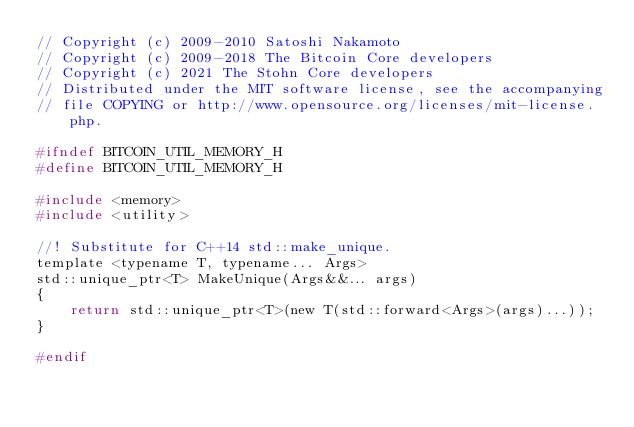<code> <loc_0><loc_0><loc_500><loc_500><_C_>// Copyright (c) 2009-2010 Satoshi Nakamoto
// Copyright (c) 2009-2018 The Bitcoin Core developers
// Copyright (c) 2021 The Stohn Core developers
// Distributed under the MIT software license, see the accompanying
// file COPYING or http://www.opensource.org/licenses/mit-license.php.

#ifndef BITCOIN_UTIL_MEMORY_H
#define BITCOIN_UTIL_MEMORY_H

#include <memory>
#include <utility>

//! Substitute for C++14 std::make_unique.
template <typename T, typename... Args>
std::unique_ptr<T> MakeUnique(Args&&... args)
{
    return std::unique_ptr<T>(new T(std::forward<Args>(args)...));
}

#endif
</code> 